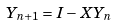<formula> <loc_0><loc_0><loc_500><loc_500>Y _ { n + 1 } = I - X Y _ { n }</formula> 